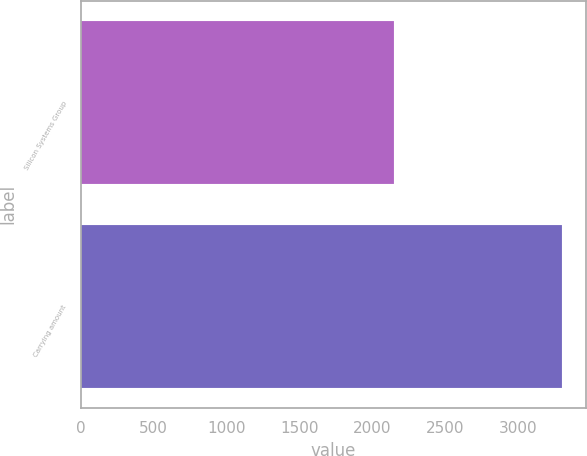Convert chart to OTSL. <chart><loc_0><loc_0><loc_500><loc_500><bar_chart><fcel>Silicon Systems Group<fcel>Carrying amount<nl><fcel>2151<fcel>3304<nl></chart> 